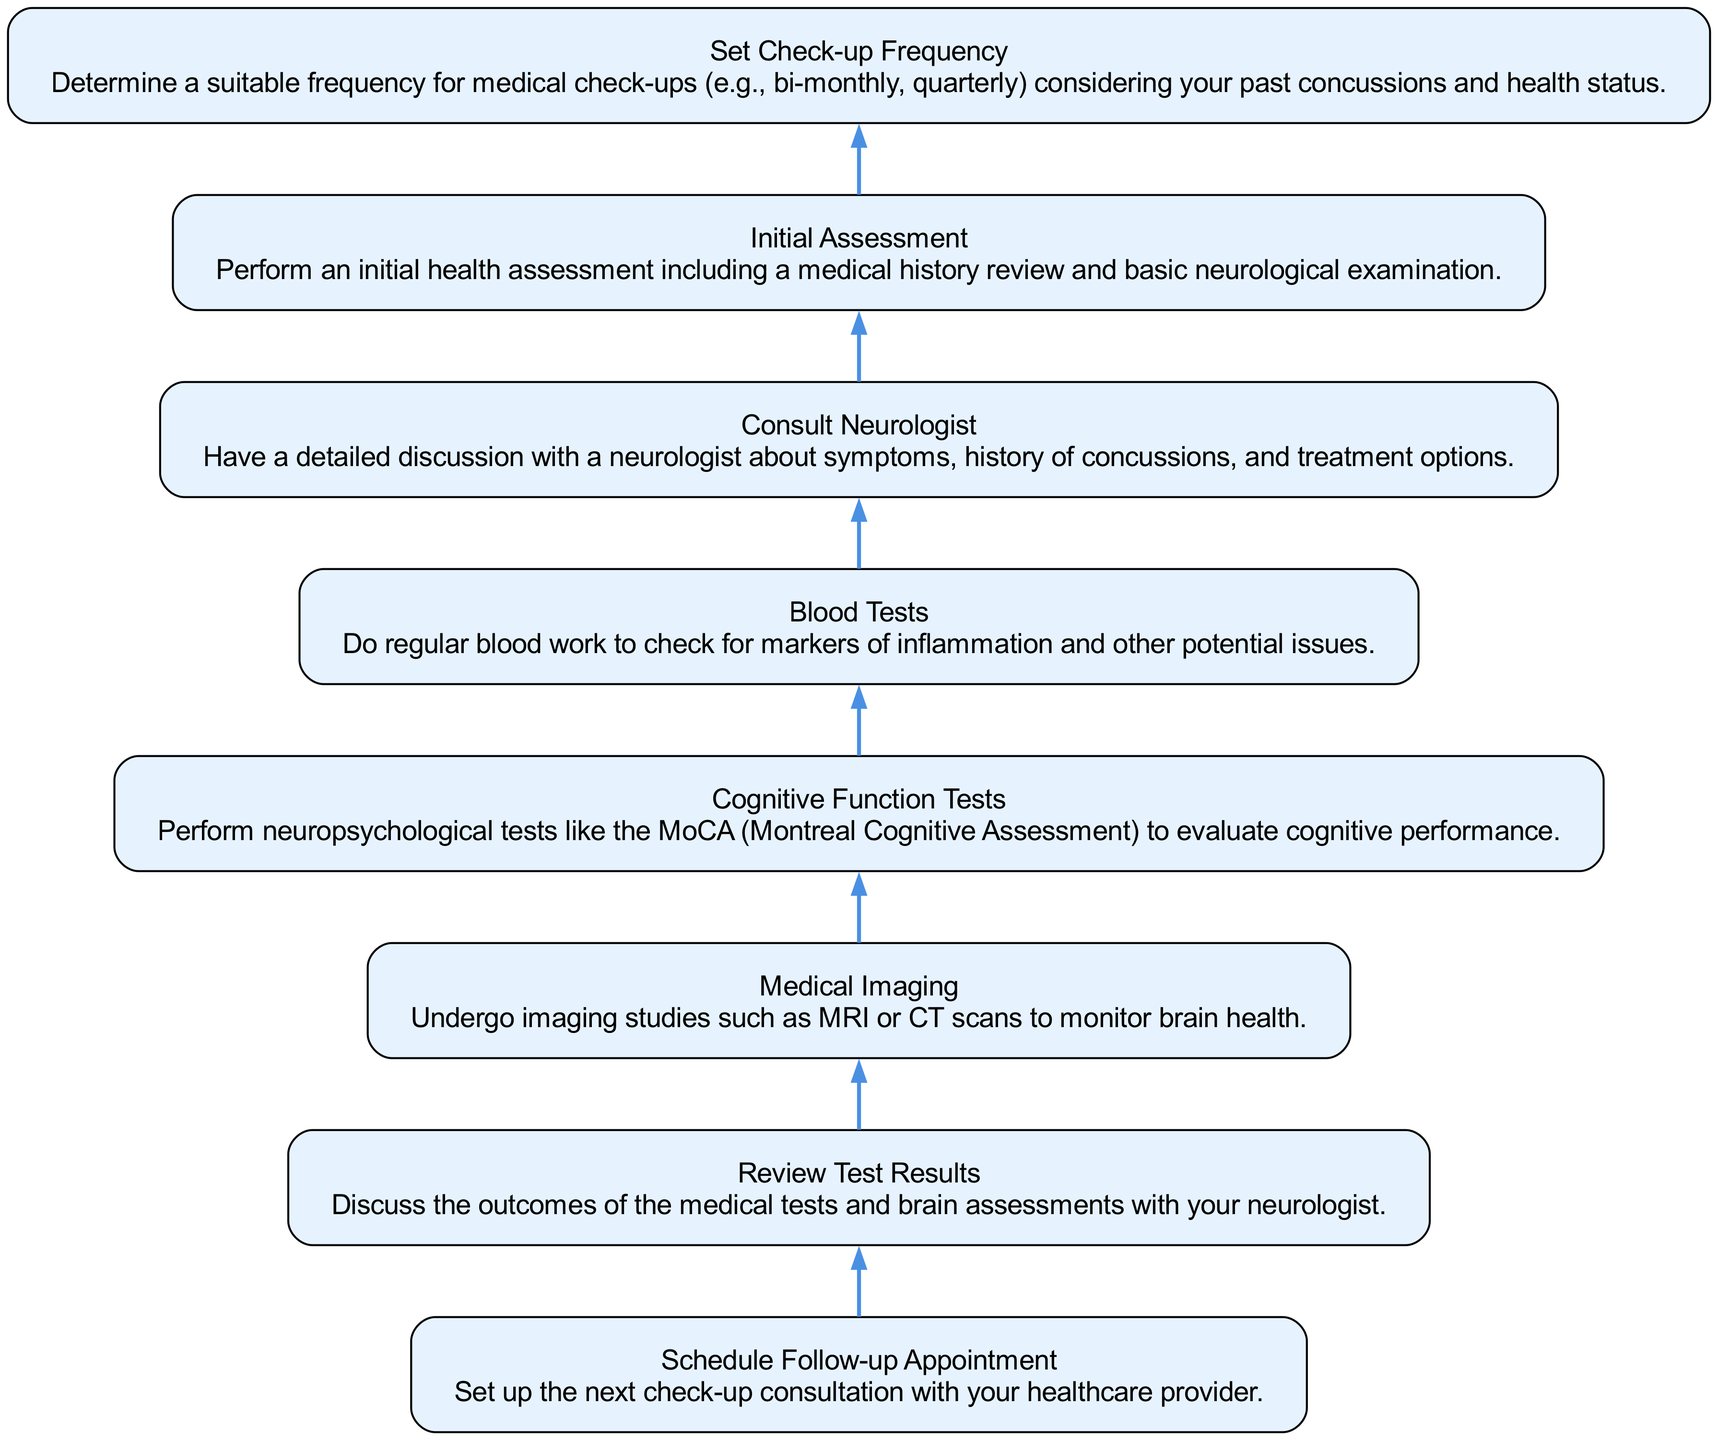What is the first step in the flowchart? The flowchart starts with "Set Check-up Frequency," which determines how often medical check-ups should occur based on the individual’s health status and history.
Answer: Set Check-up Frequency How many nodes are present in the diagram? There are eight distinct nodes in the flowchart, each representing a specific step in the structured plan for regular medical check-ups and brain health assessments.
Answer: Eight What is the last step in the flow? The final step is "Schedule Follow-up Appointment," which involves setting up the next consultation after the previous assessments and discussions.
Answer: Schedule Follow-up Appointment Which step directly follows "Consult Neurologist"? The next step after "Consult Neurologist" is "Review Test Results," which involves discussing the outcomes of tests and assessments with the neurologist.
Answer: Review Test Results If all steps are followed, how many medical assessments does a patient undergo? By following the flowchart, a patient undergoes four medical assessments: Initial Assessment, Cognitive Function Tests, Medical Imaging, and Blood Tests before scheduling the next appointment.
Answer: Four What steps must occur before "Medical Imaging"? Before "Medical Imaging," the patient must have completed "Initial Assessment" and "Consult Neurologist." This shows the requirement of discussing symptoms and reviewing health history before conducting imaging studies.
Answer: Initial Assessment and Consult Neurologist What is the relationship between "Set Check-up Frequency" and "Schedule Follow-up Appointment"? "Set Check-up Frequency" makes it possible to determine how often "Schedule Follow-up Appointment" occurs, linking the frequency of visits directly to the scheduling of these consultations.
Answer: Frequency determines scheduling What is the second step in the flowchart? The second step in the flowchart is "Initial Assessment," which includes a medical history review and neurological examination to gather baseline data regarding brain health.
Answer: Initial Assessment What type of tests does "Cognitive Function Tests" involve? "Cognitive Function Tests" involve neuropsychological assessments like the MoCA (Montreal Cognitive Assessment) that evaluates various aspects of cognitive performance.
Answer: Neuropsychological assessments 